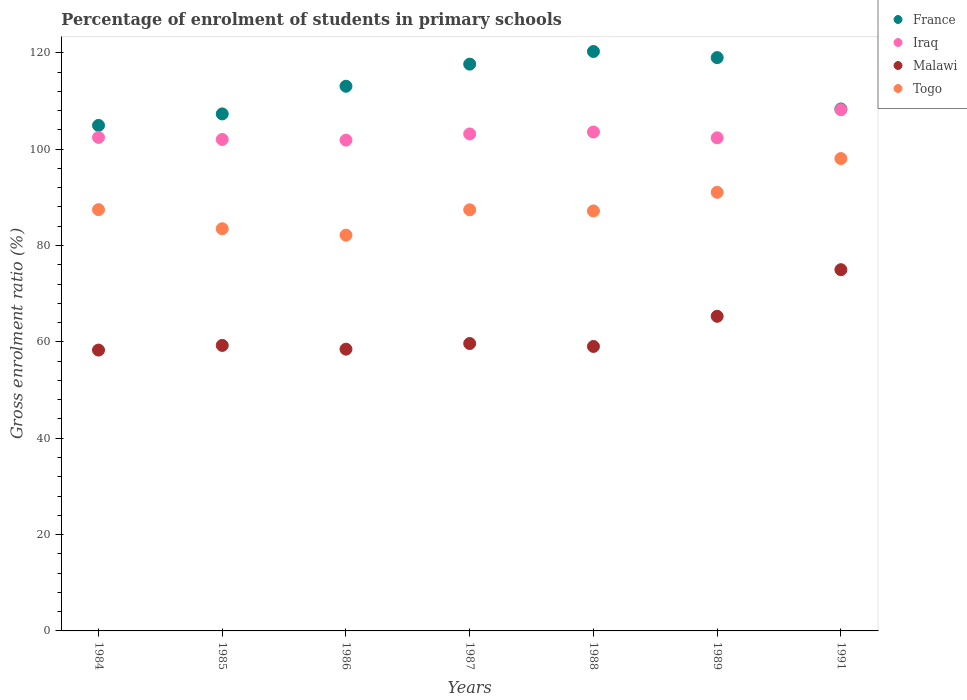How many different coloured dotlines are there?
Keep it short and to the point. 4. Is the number of dotlines equal to the number of legend labels?
Give a very brief answer. Yes. What is the percentage of students enrolled in primary schools in France in 1985?
Your answer should be very brief. 107.31. Across all years, what is the maximum percentage of students enrolled in primary schools in Malawi?
Make the answer very short. 74.98. Across all years, what is the minimum percentage of students enrolled in primary schools in France?
Provide a succinct answer. 104.93. What is the total percentage of students enrolled in primary schools in France in the graph?
Your answer should be very brief. 790.55. What is the difference between the percentage of students enrolled in primary schools in Malawi in 1985 and that in 1991?
Your response must be concise. -15.72. What is the difference between the percentage of students enrolled in primary schools in Iraq in 1985 and the percentage of students enrolled in primary schools in Malawi in 1989?
Your answer should be compact. 36.7. What is the average percentage of students enrolled in primary schools in Malawi per year?
Offer a very short reply. 62.15. In the year 1984, what is the difference between the percentage of students enrolled in primary schools in France and percentage of students enrolled in primary schools in Togo?
Your answer should be very brief. 17.49. What is the ratio of the percentage of students enrolled in primary schools in Iraq in 1984 to that in 1986?
Offer a terse response. 1.01. Is the difference between the percentage of students enrolled in primary schools in France in 1988 and 1989 greater than the difference between the percentage of students enrolled in primary schools in Togo in 1988 and 1989?
Ensure brevity in your answer.  Yes. What is the difference between the highest and the second highest percentage of students enrolled in primary schools in Malawi?
Ensure brevity in your answer.  9.67. What is the difference between the highest and the lowest percentage of students enrolled in primary schools in Togo?
Your answer should be very brief. 15.9. In how many years, is the percentage of students enrolled in primary schools in France greater than the average percentage of students enrolled in primary schools in France taken over all years?
Provide a short and direct response. 4. Is it the case that in every year, the sum of the percentage of students enrolled in primary schools in France and percentage of students enrolled in primary schools in Togo  is greater than the sum of percentage of students enrolled in primary schools in Malawi and percentage of students enrolled in primary schools in Iraq?
Provide a succinct answer. Yes. Does the percentage of students enrolled in primary schools in Togo monotonically increase over the years?
Offer a very short reply. No. Does the graph contain any zero values?
Your response must be concise. No. Does the graph contain grids?
Offer a very short reply. No. What is the title of the graph?
Offer a very short reply. Percentage of enrolment of students in primary schools. What is the label or title of the Y-axis?
Your answer should be compact. Gross enrolment ratio (%). What is the Gross enrolment ratio (%) in France in 1984?
Your response must be concise. 104.93. What is the Gross enrolment ratio (%) of Iraq in 1984?
Provide a succinct answer. 102.44. What is the Gross enrolment ratio (%) of Malawi in 1984?
Offer a very short reply. 58.29. What is the Gross enrolment ratio (%) of Togo in 1984?
Keep it short and to the point. 87.44. What is the Gross enrolment ratio (%) in France in 1985?
Keep it short and to the point. 107.31. What is the Gross enrolment ratio (%) of Iraq in 1985?
Your answer should be very brief. 102.01. What is the Gross enrolment ratio (%) in Malawi in 1985?
Your answer should be very brief. 59.26. What is the Gross enrolment ratio (%) of Togo in 1985?
Offer a very short reply. 83.48. What is the Gross enrolment ratio (%) in France in 1986?
Ensure brevity in your answer.  113.06. What is the Gross enrolment ratio (%) of Iraq in 1986?
Ensure brevity in your answer.  101.87. What is the Gross enrolment ratio (%) in Malawi in 1986?
Ensure brevity in your answer.  58.48. What is the Gross enrolment ratio (%) in Togo in 1986?
Give a very brief answer. 82.15. What is the Gross enrolment ratio (%) of France in 1987?
Provide a succinct answer. 117.64. What is the Gross enrolment ratio (%) of Iraq in 1987?
Ensure brevity in your answer.  103.16. What is the Gross enrolment ratio (%) of Malawi in 1987?
Your answer should be very brief. 59.66. What is the Gross enrolment ratio (%) of Togo in 1987?
Your answer should be compact. 87.41. What is the Gross enrolment ratio (%) of France in 1988?
Offer a very short reply. 120.27. What is the Gross enrolment ratio (%) in Iraq in 1988?
Provide a short and direct response. 103.56. What is the Gross enrolment ratio (%) of Malawi in 1988?
Your answer should be very brief. 59.04. What is the Gross enrolment ratio (%) in Togo in 1988?
Offer a terse response. 87.17. What is the Gross enrolment ratio (%) in France in 1989?
Ensure brevity in your answer.  119. What is the Gross enrolment ratio (%) in Iraq in 1989?
Your answer should be compact. 102.35. What is the Gross enrolment ratio (%) of Malawi in 1989?
Give a very brief answer. 65.31. What is the Gross enrolment ratio (%) in Togo in 1989?
Keep it short and to the point. 91.04. What is the Gross enrolment ratio (%) of France in 1991?
Your response must be concise. 108.34. What is the Gross enrolment ratio (%) of Iraq in 1991?
Offer a very short reply. 108.19. What is the Gross enrolment ratio (%) of Malawi in 1991?
Your response must be concise. 74.98. What is the Gross enrolment ratio (%) of Togo in 1991?
Your answer should be very brief. 98.04. Across all years, what is the maximum Gross enrolment ratio (%) in France?
Your answer should be very brief. 120.27. Across all years, what is the maximum Gross enrolment ratio (%) in Iraq?
Provide a short and direct response. 108.19. Across all years, what is the maximum Gross enrolment ratio (%) of Malawi?
Ensure brevity in your answer.  74.98. Across all years, what is the maximum Gross enrolment ratio (%) of Togo?
Your answer should be very brief. 98.04. Across all years, what is the minimum Gross enrolment ratio (%) of France?
Make the answer very short. 104.93. Across all years, what is the minimum Gross enrolment ratio (%) in Iraq?
Your response must be concise. 101.87. Across all years, what is the minimum Gross enrolment ratio (%) of Malawi?
Keep it short and to the point. 58.29. Across all years, what is the minimum Gross enrolment ratio (%) of Togo?
Give a very brief answer. 82.15. What is the total Gross enrolment ratio (%) in France in the graph?
Give a very brief answer. 790.55. What is the total Gross enrolment ratio (%) in Iraq in the graph?
Ensure brevity in your answer.  723.57. What is the total Gross enrolment ratio (%) of Malawi in the graph?
Your response must be concise. 435.02. What is the total Gross enrolment ratio (%) of Togo in the graph?
Provide a short and direct response. 616.73. What is the difference between the Gross enrolment ratio (%) of France in 1984 and that in 1985?
Make the answer very short. -2.38. What is the difference between the Gross enrolment ratio (%) in Iraq in 1984 and that in 1985?
Offer a very short reply. 0.43. What is the difference between the Gross enrolment ratio (%) in Malawi in 1984 and that in 1985?
Provide a short and direct response. -0.97. What is the difference between the Gross enrolment ratio (%) of Togo in 1984 and that in 1985?
Offer a terse response. 3.97. What is the difference between the Gross enrolment ratio (%) in France in 1984 and that in 1986?
Offer a very short reply. -8.12. What is the difference between the Gross enrolment ratio (%) of Iraq in 1984 and that in 1986?
Your response must be concise. 0.56. What is the difference between the Gross enrolment ratio (%) in Malawi in 1984 and that in 1986?
Your answer should be compact. -0.19. What is the difference between the Gross enrolment ratio (%) in Togo in 1984 and that in 1986?
Provide a short and direct response. 5.3. What is the difference between the Gross enrolment ratio (%) of France in 1984 and that in 1987?
Make the answer very short. -12.71. What is the difference between the Gross enrolment ratio (%) in Iraq in 1984 and that in 1987?
Offer a very short reply. -0.72. What is the difference between the Gross enrolment ratio (%) of Malawi in 1984 and that in 1987?
Offer a terse response. -1.36. What is the difference between the Gross enrolment ratio (%) in Togo in 1984 and that in 1987?
Make the answer very short. 0.04. What is the difference between the Gross enrolment ratio (%) of France in 1984 and that in 1988?
Provide a succinct answer. -15.33. What is the difference between the Gross enrolment ratio (%) in Iraq in 1984 and that in 1988?
Give a very brief answer. -1.12. What is the difference between the Gross enrolment ratio (%) in Malawi in 1984 and that in 1988?
Provide a succinct answer. -0.75. What is the difference between the Gross enrolment ratio (%) in Togo in 1984 and that in 1988?
Your answer should be compact. 0.27. What is the difference between the Gross enrolment ratio (%) in France in 1984 and that in 1989?
Ensure brevity in your answer.  -14.07. What is the difference between the Gross enrolment ratio (%) of Iraq in 1984 and that in 1989?
Provide a short and direct response. 0.09. What is the difference between the Gross enrolment ratio (%) in Malawi in 1984 and that in 1989?
Your response must be concise. -7.01. What is the difference between the Gross enrolment ratio (%) in Togo in 1984 and that in 1989?
Your answer should be compact. -3.59. What is the difference between the Gross enrolment ratio (%) in France in 1984 and that in 1991?
Make the answer very short. -3.4. What is the difference between the Gross enrolment ratio (%) in Iraq in 1984 and that in 1991?
Keep it short and to the point. -5.75. What is the difference between the Gross enrolment ratio (%) of Malawi in 1984 and that in 1991?
Offer a very short reply. -16.69. What is the difference between the Gross enrolment ratio (%) of Togo in 1984 and that in 1991?
Offer a terse response. -10.6. What is the difference between the Gross enrolment ratio (%) in France in 1985 and that in 1986?
Offer a very short reply. -5.74. What is the difference between the Gross enrolment ratio (%) in Iraq in 1985 and that in 1986?
Your answer should be compact. 0.14. What is the difference between the Gross enrolment ratio (%) of Malawi in 1985 and that in 1986?
Offer a terse response. 0.78. What is the difference between the Gross enrolment ratio (%) of Togo in 1985 and that in 1986?
Offer a very short reply. 1.33. What is the difference between the Gross enrolment ratio (%) of France in 1985 and that in 1987?
Make the answer very short. -10.33. What is the difference between the Gross enrolment ratio (%) in Iraq in 1985 and that in 1987?
Give a very brief answer. -1.15. What is the difference between the Gross enrolment ratio (%) in Malawi in 1985 and that in 1987?
Provide a succinct answer. -0.39. What is the difference between the Gross enrolment ratio (%) of Togo in 1985 and that in 1987?
Offer a terse response. -3.93. What is the difference between the Gross enrolment ratio (%) in France in 1985 and that in 1988?
Give a very brief answer. -12.95. What is the difference between the Gross enrolment ratio (%) of Iraq in 1985 and that in 1988?
Your answer should be compact. -1.55. What is the difference between the Gross enrolment ratio (%) of Malawi in 1985 and that in 1988?
Give a very brief answer. 0.22. What is the difference between the Gross enrolment ratio (%) of Togo in 1985 and that in 1988?
Make the answer very short. -3.7. What is the difference between the Gross enrolment ratio (%) of France in 1985 and that in 1989?
Provide a succinct answer. -11.69. What is the difference between the Gross enrolment ratio (%) of Iraq in 1985 and that in 1989?
Give a very brief answer. -0.34. What is the difference between the Gross enrolment ratio (%) of Malawi in 1985 and that in 1989?
Give a very brief answer. -6.04. What is the difference between the Gross enrolment ratio (%) in Togo in 1985 and that in 1989?
Your answer should be compact. -7.56. What is the difference between the Gross enrolment ratio (%) of France in 1985 and that in 1991?
Your answer should be very brief. -1.02. What is the difference between the Gross enrolment ratio (%) of Iraq in 1985 and that in 1991?
Ensure brevity in your answer.  -6.18. What is the difference between the Gross enrolment ratio (%) in Malawi in 1985 and that in 1991?
Offer a very short reply. -15.72. What is the difference between the Gross enrolment ratio (%) of Togo in 1985 and that in 1991?
Your answer should be very brief. -14.57. What is the difference between the Gross enrolment ratio (%) of France in 1986 and that in 1987?
Ensure brevity in your answer.  -4.59. What is the difference between the Gross enrolment ratio (%) of Iraq in 1986 and that in 1987?
Make the answer very short. -1.28. What is the difference between the Gross enrolment ratio (%) of Malawi in 1986 and that in 1987?
Offer a very short reply. -1.17. What is the difference between the Gross enrolment ratio (%) in Togo in 1986 and that in 1987?
Make the answer very short. -5.26. What is the difference between the Gross enrolment ratio (%) in France in 1986 and that in 1988?
Provide a short and direct response. -7.21. What is the difference between the Gross enrolment ratio (%) of Iraq in 1986 and that in 1988?
Keep it short and to the point. -1.68. What is the difference between the Gross enrolment ratio (%) in Malawi in 1986 and that in 1988?
Ensure brevity in your answer.  -0.56. What is the difference between the Gross enrolment ratio (%) in Togo in 1986 and that in 1988?
Provide a succinct answer. -5.03. What is the difference between the Gross enrolment ratio (%) of France in 1986 and that in 1989?
Your answer should be compact. -5.94. What is the difference between the Gross enrolment ratio (%) of Iraq in 1986 and that in 1989?
Offer a terse response. -0.48. What is the difference between the Gross enrolment ratio (%) in Malawi in 1986 and that in 1989?
Keep it short and to the point. -6.82. What is the difference between the Gross enrolment ratio (%) of Togo in 1986 and that in 1989?
Offer a very short reply. -8.89. What is the difference between the Gross enrolment ratio (%) in France in 1986 and that in 1991?
Offer a very short reply. 4.72. What is the difference between the Gross enrolment ratio (%) of Iraq in 1986 and that in 1991?
Provide a short and direct response. -6.31. What is the difference between the Gross enrolment ratio (%) of Malawi in 1986 and that in 1991?
Ensure brevity in your answer.  -16.5. What is the difference between the Gross enrolment ratio (%) of Togo in 1986 and that in 1991?
Provide a short and direct response. -15.9. What is the difference between the Gross enrolment ratio (%) of France in 1987 and that in 1988?
Offer a terse response. -2.62. What is the difference between the Gross enrolment ratio (%) in Iraq in 1987 and that in 1988?
Provide a short and direct response. -0.4. What is the difference between the Gross enrolment ratio (%) in Malawi in 1987 and that in 1988?
Offer a very short reply. 0.61. What is the difference between the Gross enrolment ratio (%) in Togo in 1987 and that in 1988?
Provide a succinct answer. 0.23. What is the difference between the Gross enrolment ratio (%) in France in 1987 and that in 1989?
Give a very brief answer. -1.36. What is the difference between the Gross enrolment ratio (%) of Iraq in 1987 and that in 1989?
Offer a terse response. 0.8. What is the difference between the Gross enrolment ratio (%) of Malawi in 1987 and that in 1989?
Make the answer very short. -5.65. What is the difference between the Gross enrolment ratio (%) in Togo in 1987 and that in 1989?
Your answer should be compact. -3.63. What is the difference between the Gross enrolment ratio (%) of France in 1987 and that in 1991?
Provide a succinct answer. 9.31. What is the difference between the Gross enrolment ratio (%) in Iraq in 1987 and that in 1991?
Ensure brevity in your answer.  -5.03. What is the difference between the Gross enrolment ratio (%) of Malawi in 1987 and that in 1991?
Your answer should be compact. -15.32. What is the difference between the Gross enrolment ratio (%) of Togo in 1987 and that in 1991?
Offer a terse response. -10.64. What is the difference between the Gross enrolment ratio (%) of France in 1988 and that in 1989?
Provide a succinct answer. 1.27. What is the difference between the Gross enrolment ratio (%) in Iraq in 1988 and that in 1989?
Provide a succinct answer. 1.2. What is the difference between the Gross enrolment ratio (%) of Malawi in 1988 and that in 1989?
Your answer should be compact. -6.26. What is the difference between the Gross enrolment ratio (%) of Togo in 1988 and that in 1989?
Give a very brief answer. -3.87. What is the difference between the Gross enrolment ratio (%) of France in 1988 and that in 1991?
Provide a succinct answer. 11.93. What is the difference between the Gross enrolment ratio (%) in Iraq in 1988 and that in 1991?
Offer a terse response. -4.63. What is the difference between the Gross enrolment ratio (%) in Malawi in 1988 and that in 1991?
Ensure brevity in your answer.  -15.94. What is the difference between the Gross enrolment ratio (%) of Togo in 1988 and that in 1991?
Give a very brief answer. -10.87. What is the difference between the Gross enrolment ratio (%) in France in 1989 and that in 1991?
Your answer should be compact. 10.66. What is the difference between the Gross enrolment ratio (%) in Iraq in 1989 and that in 1991?
Your answer should be very brief. -5.83. What is the difference between the Gross enrolment ratio (%) in Malawi in 1989 and that in 1991?
Provide a succinct answer. -9.67. What is the difference between the Gross enrolment ratio (%) of Togo in 1989 and that in 1991?
Your response must be concise. -7. What is the difference between the Gross enrolment ratio (%) of France in 1984 and the Gross enrolment ratio (%) of Iraq in 1985?
Your answer should be compact. 2.92. What is the difference between the Gross enrolment ratio (%) in France in 1984 and the Gross enrolment ratio (%) in Malawi in 1985?
Make the answer very short. 45.67. What is the difference between the Gross enrolment ratio (%) in France in 1984 and the Gross enrolment ratio (%) in Togo in 1985?
Your answer should be compact. 21.46. What is the difference between the Gross enrolment ratio (%) in Iraq in 1984 and the Gross enrolment ratio (%) in Malawi in 1985?
Ensure brevity in your answer.  43.18. What is the difference between the Gross enrolment ratio (%) in Iraq in 1984 and the Gross enrolment ratio (%) in Togo in 1985?
Your answer should be very brief. 18.96. What is the difference between the Gross enrolment ratio (%) in Malawi in 1984 and the Gross enrolment ratio (%) in Togo in 1985?
Provide a short and direct response. -25.18. What is the difference between the Gross enrolment ratio (%) of France in 1984 and the Gross enrolment ratio (%) of Iraq in 1986?
Your answer should be compact. 3.06. What is the difference between the Gross enrolment ratio (%) of France in 1984 and the Gross enrolment ratio (%) of Malawi in 1986?
Make the answer very short. 46.45. What is the difference between the Gross enrolment ratio (%) in France in 1984 and the Gross enrolment ratio (%) in Togo in 1986?
Give a very brief answer. 22.79. What is the difference between the Gross enrolment ratio (%) of Iraq in 1984 and the Gross enrolment ratio (%) of Malawi in 1986?
Provide a succinct answer. 43.96. What is the difference between the Gross enrolment ratio (%) of Iraq in 1984 and the Gross enrolment ratio (%) of Togo in 1986?
Offer a terse response. 20.29. What is the difference between the Gross enrolment ratio (%) in Malawi in 1984 and the Gross enrolment ratio (%) in Togo in 1986?
Your answer should be compact. -23.85. What is the difference between the Gross enrolment ratio (%) of France in 1984 and the Gross enrolment ratio (%) of Iraq in 1987?
Your answer should be compact. 1.78. What is the difference between the Gross enrolment ratio (%) in France in 1984 and the Gross enrolment ratio (%) in Malawi in 1987?
Make the answer very short. 45.28. What is the difference between the Gross enrolment ratio (%) of France in 1984 and the Gross enrolment ratio (%) of Togo in 1987?
Your response must be concise. 17.53. What is the difference between the Gross enrolment ratio (%) of Iraq in 1984 and the Gross enrolment ratio (%) of Malawi in 1987?
Provide a short and direct response. 42.78. What is the difference between the Gross enrolment ratio (%) of Iraq in 1984 and the Gross enrolment ratio (%) of Togo in 1987?
Make the answer very short. 15.03. What is the difference between the Gross enrolment ratio (%) in Malawi in 1984 and the Gross enrolment ratio (%) in Togo in 1987?
Ensure brevity in your answer.  -29.11. What is the difference between the Gross enrolment ratio (%) of France in 1984 and the Gross enrolment ratio (%) of Iraq in 1988?
Offer a very short reply. 1.38. What is the difference between the Gross enrolment ratio (%) of France in 1984 and the Gross enrolment ratio (%) of Malawi in 1988?
Provide a succinct answer. 45.89. What is the difference between the Gross enrolment ratio (%) in France in 1984 and the Gross enrolment ratio (%) in Togo in 1988?
Keep it short and to the point. 17.76. What is the difference between the Gross enrolment ratio (%) of Iraq in 1984 and the Gross enrolment ratio (%) of Malawi in 1988?
Give a very brief answer. 43.39. What is the difference between the Gross enrolment ratio (%) in Iraq in 1984 and the Gross enrolment ratio (%) in Togo in 1988?
Your answer should be very brief. 15.27. What is the difference between the Gross enrolment ratio (%) in Malawi in 1984 and the Gross enrolment ratio (%) in Togo in 1988?
Keep it short and to the point. -28.88. What is the difference between the Gross enrolment ratio (%) of France in 1984 and the Gross enrolment ratio (%) of Iraq in 1989?
Give a very brief answer. 2.58. What is the difference between the Gross enrolment ratio (%) in France in 1984 and the Gross enrolment ratio (%) in Malawi in 1989?
Your answer should be compact. 39.63. What is the difference between the Gross enrolment ratio (%) in France in 1984 and the Gross enrolment ratio (%) in Togo in 1989?
Provide a short and direct response. 13.89. What is the difference between the Gross enrolment ratio (%) in Iraq in 1984 and the Gross enrolment ratio (%) in Malawi in 1989?
Your response must be concise. 37.13. What is the difference between the Gross enrolment ratio (%) in Iraq in 1984 and the Gross enrolment ratio (%) in Togo in 1989?
Your answer should be very brief. 11.4. What is the difference between the Gross enrolment ratio (%) in Malawi in 1984 and the Gross enrolment ratio (%) in Togo in 1989?
Your answer should be very brief. -32.74. What is the difference between the Gross enrolment ratio (%) of France in 1984 and the Gross enrolment ratio (%) of Iraq in 1991?
Your answer should be compact. -3.25. What is the difference between the Gross enrolment ratio (%) in France in 1984 and the Gross enrolment ratio (%) in Malawi in 1991?
Give a very brief answer. 29.95. What is the difference between the Gross enrolment ratio (%) in France in 1984 and the Gross enrolment ratio (%) in Togo in 1991?
Provide a succinct answer. 6.89. What is the difference between the Gross enrolment ratio (%) of Iraq in 1984 and the Gross enrolment ratio (%) of Malawi in 1991?
Keep it short and to the point. 27.46. What is the difference between the Gross enrolment ratio (%) in Iraq in 1984 and the Gross enrolment ratio (%) in Togo in 1991?
Keep it short and to the point. 4.4. What is the difference between the Gross enrolment ratio (%) in Malawi in 1984 and the Gross enrolment ratio (%) in Togo in 1991?
Provide a short and direct response. -39.75. What is the difference between the Gross enrolment ratio (%) in France in 1985 and the Gross enrolment ratio (%) in Iraq in 1986?
Keep it short and to the point. 5.44. What is the difference between the Gross enrolment ratio (%) in France in 1985 and the Gross enrolment ratio (%) in Malawi in 1986?
Give a very brief answer. 48.83. What is the difference between the Gross enrolment ratio (%) of France in 1985 and the Gross enrolment ratio (%) of Togo in 1986?
Offer a terse response. 25.17. What is the difference between the Gross enrolment ratio (%) in Iraq in 1985 and the Gross enrolment ratio (%) in Malawi in 1986?
Offer a terse response. 43.53. What is the difference between the Gross enrolment ratio (%) in Iraq in 1985 and the Gross enrolment ratio (%) in Togo in 1986?
Provide a succinct answer. 19.86. What is the difference between the Gross enrolment ratio (%) in Malawi in 1985 and the Gross enrolment ratio (%) in Togo in 1986?
Ensure brevity in your answer.  -22.88. What is the difference between the Gross enrolment ratio (%) in France in 1985 and the Gross enrolment ratio (%) in Iraq in 1987?
Give a very brief answer. 4.16. What is the difference between the Gross enrolment ratio (%) in France in 1985 and the Gross enrolment ratio (%) in Malawi in 1987?
Give a very brief answer. 47.66. What is the difference between the Gross enrolment ratio (%) of France in 1985 and the Gross enrolment ratio (%) of Togo in 1987?
Keep it short and to the point. 19.91. What is the difference between the Gross enrolment ratio (%) in Iraq in 1985 and the Gross enrolment ratio (%) in Malawi in 1987?
Offer a very short reply. 42.35. What is the difference between the Gross enrolment ratio (%) of Iraq in 1985 and the Gross enrolment ratio (%) of Togo in 1987?
Provide a short and direct response. 14.6. What is the difference between the Gross enrolment ratio (%) of Malawi in 1985 and the Gross enrolment ratio (%) of Togo in 1987?
Make the answer very short. -28.14. What is the difference between the Gross enrolment ratio (%) in France in 1985 and the Gross enrolment ratio (%) in Iraq in 1988?
Give a very brief answer. 3.76. What is the difference between the Gross enrolment ratio (%) in France in 1985 and the Gross enrolment ratio (%) in Malawi in 1988?
Provide a short and direct response. 48.27. What is the difference between the Gross enrolment ratio (%) in France in 1985 and the Gross enrolment ratio (%) in Togo in 1988?
Your response must be concise. 20.14. What is the difference between the Gross enrolment ratio (%) of Iraq in 1985 and the Gross enrolment ratio (%) of Malawi in 1988?
Your response must be concise. 42.96. What is the difference between the Gross enrolment ratio (%) of Iraq in 1985 and the Gross enrolment ratio (%) of Togo in 1988?
Provide a succinct answer. 14.84. What is the difference between the Gross enrolment ratio (%) of Malawi in 1985 and the Gross enrolment ratio (%) of Togo in 1988?
Your response must be concise. -27.91. What is the difference between the Gross enrolment ratio (%) in France in 1985 and the Gross enrolment ratio (%) in Iraq in 1989?
Provide a short and direct response. 4.96. What is the difference between the Gross enrolment ratio (%) in France in 1985 and the Gross enrolment ratio (%) in Malawi in 1989?
Offer a very short reply. 42.01. What is the difference between the Gross enrolment ratio (%) of France in 1985 and the Gross enrolment ratio (%) of Togo in 1989?
Ensure brevity in your answer.  16.27. What is the difference between the Gross enrolment ratio (%) of Iraq in 1985 and the Gross enrolment ratio (%) of Malawi in 1989?
Keep it short and to the point. 36.7. What is the difference between the Gross enrolment ratio (%) of Iraq in 1985 and the Gross enrolment ratio (%) of Togo in 1989?
Offer a very short reply. 10.97. What is the difference between the Gross enrolment ratio (%) in Malawi in 1985 and the Gross enrolment ratio (%) in Togo in 1989?
Give a very brief answer. -31.78. What is the difference between the Gross enrolment ratio (%) in France in 1985 and the Gross enrolment ratio (%) in Iraq in 1991?
Your answer should be compact. -0.87. What is the difference between the Gross enrolment ratio (%) of France in 1985 and the Gross enrolment ratio (%) of Malawi in 1991?
Keep it short and to the point. 32.33. What is the difference between the Gross enrolment ratio (%) of France in 1985 and the Gross enrolment ratio (%) of Togo in 1991?
Your response must be concise. 9.27. What is the difference between the Gross enrolment ratio (%) in Iraq in 1985 and the Gross enrolment ratio (%) in Malawi in 1991?
Your response must be concise. 27.03. What is the difference between the Gross enrolment ratio (%) of Iraq in 1985 and the Gross enrolment ratio (%) of Togo in 1991?
Ensure brevity in your answer.  3.97. What is the difference between the Gross enrolment ratio (%) of Malawi in 1985 and the Gross enrolment ratio (%) of Togo in 1991?
Ensure brevity in your answer.  -38.78. What is the difference between the Gross enrolment ratio (%) of France in 1986 and the Gross enrolment ratio (%) of Iraq in 1987?
Offer a terse response. 9.9. What is the difference between the Gross enrolment ratio (%) of France in 1986 and the Gross enrolment ratio (%) of Malawi in 1987?
Make the answer very short. 53.4. What is the difference between the Gross enrolment ratio (%) of France in 1986 and the Gross enrolment ratio (%) of Togo in 1987?
Offer a terse response. 25.65. What is the difference between the Gross enrolment ratio (%) in Iraq in 1986 and the Gross enrolment ratio (%) in Malawi in 1987?
Ensure brevity in your answer.  42.22. What is the difference between the Gross enrolment ratio (%) of Iraq in 1986 and the Gross enrolment ratio (%) of Togo in 1987?
Offer a very short reply. 14.47. What is the difference between the Gross enrolment ratio (%) in Malawi in 1986 and the Gross enrolment ratio (%) in Togo in 1987?
Keep it short and to the point. -28.92. What is the difference between the Gross enrolment ratio (%) of France in 1986 and the Gross enrolment ratio (%) of Iraq in 1988?
Give a very brief answer. 9.5. What is the difference between the Gross enrolment ratio (%) of France in 1986 and the Gross enrolment ratio (%) of Malawi in 1988?
Your response must be concise. 54.01. What is the difference between the Gross enrolment ratio (%) in France in 1986 and the Gross enrolment ratio (%) in Togo in 1988?
Your response must be concise. 25.88. What is the difference between the Gross enrolment ratio (%) in Iraq in 1986 and the Gross enrolment ratio (%) in Malawi in 1988?
Your answer should be compact. 42.83. What is the difference between the Gross enrolment ratio (%) of Iraq in 1986 and the Gross enrolment ratio (%) of Togo in 1988?
Your response must be concise. 14.7. What is the difference between the Gross enrolment ratio (%) of Malawi in 1986 and the Gross enrolment ratio (%) of Togo in 1988?
Provide a succinct answer. -28.69. What is the difference between the Gross enrolment ratio (%) in France in 1986 and the Gross enrolment ratio (%) in Iraq in 1989?
Make the answer very short. 10.7. What is the difference between the Gross enrolment ratio (%) in France in 1986 and the Gross enrolment ratio (%) in Malawi in 1989?
Provide a succinct answer. 47.75. What is the difference between the Gross enrolment ratio (%) of France in 1986 and the Gross enrolment ratio (%) of Togo in 1989?
Offer a very short reply. 22.02. What is the difference between the Gross enrolment ratio (%) of Iraq in 1986 and the Gross enrolment ratio (%) of Malawi in 1989?
Offer a terse response. 36.57. What is the difference between the Gross enrolment ratio (%) in Iraq in 1986 and the Gross enrolment ratio (%) in Togo in 1989?
Your answer should be compact. 10.84. What is the difference between the Gross enrolment ratio (%) in Malawi in 1986 and the Gross enrolment ratio (%) in Togo in 1989?
Provide a succinct answer. -32.56. What is the difference between the Gross enrolment ratio (%) in France in 1986 and the Gross enrolment ratio (%) in Iraq in 1991?
Provide a succinct answer. 4.87. What is the difference between the Gross enrolment ratio (%) in France in 1986 and the Gross enrolment ratio (%) in Malawi in 1991?
Ensure brevity in your answer.  38.08. What is the difference between the Gross enrolment ratio (%) of France in 1986 and the Gross enrolment ratio (%) of Togo in 1991?
Give a very brief answer. 15.01. What is the difference between the Gross enrolment ratio (%) in Iraq in 1986 and the Gross enrolment ratio (%) in Malawi in 1991?
Your response must be concise. 26.89. What is the difference between the Gross enrolment ratio (%) in Iraq in 1986 and the Gross enrolment ratio (%) in Togo in 1991?
Your answer should be very brief. 3.83. What is the difference between the Gross enrolment ratio (%) of Malawi in 1986 and the Gross enrolment ratio (%) of Togo in 1991?
Offer a terse response. -39.56. What is the difference between the Gross enrolment ratio (%) of France in 1987 and the Gross enrolment ratio (%) of Iraq in 1988?
Keep it short and to the point. 14.09. What is the difference between the Gross enrolment ratio (%) of France in 1987 and the Gross enrolment ratio (%) of Malawi in 1988?
Your answer should be very brief. 58.6. What is the difference between the Gross enrolment ratio (%) of France in 1987 and the Gross enrolment ratio (%) of Togo in 1988?
Your answer should be very brief. 30.47. What is the difference between the Gross enrolment ratio (%) of Iraq in 1987 and the Gross enrolment ratio (%) of Malawi in 1988?
Offer a very short reply. 44.11. What is the difference between the Gross enrolment ratio (%) in Iraq in 1987 and the Gross enrolment ratio (%) in Togo in 1988?
Provide a succinct answer. 15.98. What is the difference between the Gross enrolment ratio (%) of Malawi in 1987 and the Gross enrolment ratio (%) of Togo in 1988?
Give a very brief answer. -27.52. What is the difference between the Gross enrolment ratio (%) of France in 1987 and the Gross enrolment ratio (%) of Iraq in 1989?
Provide a succinct answer. 15.29. What is the difference between the Gross enrolment ratio (%) in France in 1987 and the Gross enrolment ratio (%) in Malawi in 1989?
Provide a short and direct response. 52.34. What is the difference between the Gross enrolment ratio (%) of France in 1987 and the Gross enrolment ratio (%) of Togo in 1989?
Your answer should be compact. 26.6. What is the difference between the Gross enrolment ratio (%) in Iraq in 1987 and the Gross enrolment ratio (%) in Malawi in 1989?
Keep it short and to the point. 37.85. What is the difference between the Gross enrolment ratio (%) of Iraq in 1987 and the Gross enrolment ratio (%) of Togo in 1989?
Your answer should be very brief. 12.12. What is the difference between the Gross enrolment ratio (%) of Malawi in 1987 and the Gross enrolment ratio (%) of Togo in 1989?
Your response must be concise. -31.38. What is the difference between the Gross enrolment ratio (%) of France in 1987 and the Gross enrolment ratio (%) of Iraq in 1991?
Ensure brevity in your answer.  9.46. What is the difference between the Gross enrolment ratio (%) of France in 1987 and the Gross enrolment ratio (%) of Malawi in 1991?
Ensure brevity in your answer.  42.66. What is the difference between the Gross enrolment ratio (%) of France in 1987 and the Gross enrolment ratio (%) of Togo in 1991?
Keep it short and to the point. 19.6. What is the difference between the Gross enrolment ratio (%) in Iraq in 1987 and the Gross enrolment ratio (%) in Malawi in 1991?
Make the answer very short. 28.18. What is the difference between the Gross enrolment ratio (%) of Iraq in 1987 and the Gross enrolment ratio (%) of Togo in 1991?
Keep it short and to the point. 5.11. What is the difference between the Gross enrolment ratio (%) in Malawi in 1987 and the Gross enrolment ratio (%) in Togo in 1991?
Ensure brevity in your answer.  -38.39. What is the difference between the Gross enrolment ratio (%) of France in 1988 and the Gross enrolment ratio (%) of Iraq in 1989?
Provide a short and direct response. 17.91. What is the difference between the Gross enrolment ratio (%) of France in 1988 and the Gross enrolment ratio (%) of Malawi in 1989?
Ensure brevity in your answer.  54.96. What is the difference between the Gross enrolment ratio (%) in France in 1988 and the Gross enrolment ratio (%) in Togo in 1989?
Your answer should be compact. 29.23. What is the difference between the Gross enrolment ratio (%) of Iraq in 1988 and the Gross enrolment ratio (%) of Malawi in 1989?
Your answer should be very brief. 38.25. What is the difference between the Gross enrolment ratio (%) in Iraq in 1988 and the Gross enrolment ratio (%) in Togo in 1989?
Your answer should be compact. 12.52. What is the difference between the Gross enrolment ratio (%) in Malawi in 1988 and the Gross enrolment ratio (%) in Togo in 1989?
Keep it short and to the point. -31.99. What is the difference between the Gross enrolment ratio (%) of France in 1988 and the Gross enrolment ratio (%) of Iraq in 1991?
Offer a terse response. 12.08. What is the difference between the Gross enrolment ratio (%) in France in 1988 and the Gross enrolment ratio (%) in Malawi in 1991?
Your answer should be compact. 45.29. What is the difference between the Gross enrolment ratio (%) of France in 1988 and the Gross enrolment ratio (%) of Togo in 1991?
Keep it short and to the point. 22.22. What is the difference between the Gross enrolment ratio (%) in Iraq in 1988 and the Gross enrolment ratio (%) in Malawi in 1991?
Make the answer very short. 28.58. What is the difference between the Gross enrolment ratio (%) in Iraq in 1988 and the Gross enrolment ratio (%) in Togo in 1991?
Offer a very short reply. 5.51. What is the difference between the Gross enrolment ratio (%) in Malawi in 1988 and the Gross enrolment ratio (%) in Togo in 1991?
Offer a terse response. -39. What is the difference between the Gross enrolment ratio (%) of France in 1989 and the Gross enrolment ratio (%) of Iraq in 1991?
Provide a succinct answer. 10.81. What is the difference between the Gross enrolment ratio (%) of France in 1989 and the Gross enrolment ratio (%) of Malawi in 1991?
Keep it short and to the point. 44.02. What is the difference between the Gross enrolment ratio (%) in France in 1989 and the Gross enrolment ratio (%) in Togo in 1991?
Provide a short and direct response. 20.96. What is the difference between the Gross enrolment ratio (%) of Iraq in 1989 and the Gross enrolment ratio (%) of Malawi in 1991?
Offer a terse response. 27.37. What is the difference between the Gross enrolment ratio (%) of Iraq in 1989 and the Gross enrolment ratio (%) of Togo in 1991?
Keep it short and to the point. 4.31. What is the difference between the Gross enrolment ratio (%) in Malawi in 1989 and the Gross enrolment ratio (%) in Togo in 1991?
Your answer should be very brief. -32.74. What is the average Gross enrolment ratio (%) in France per year?
Offer a very short reply. 112.94. What is the average Gross enrolment ratio (%) of Iraq per year?
Provide a succinct answer. 103.37. What is the average Gross enrolment ratio (%) of Malawi per year?
Your answer should be very brief. 62.15. What is the average Gross enrolment ratio (%) of Togo per year?
Keep it short and to the point. 88.1. In the year 1984, what is the difference between the Gross enrolment ratio (%) in France and Gross enrolment ratio (%) in Iraq?
Ensure brevity in your answer.  2.49. In the year 1984, what is the difference between the Gross enrolment ratio (%) in France and Gross enrolment ratio (%) in Malawi?
Provide a succinct answer. 46.64. In the year 1984, what is the difference between the Gross enrolment ratio (%) of France and Gross enrolment ratio (%) of Togo?
Give a very brief answer. 17.49. In the year 1984, what is the difference between the Gross enrolment ratio (%) of Iraq and Gross enrolment ratio (%) of Malawi?
Ensure brevity in your answer.  44.14. In the year 1984, what is the difference between the Gross enrolment ratio (%) of Iraq and Gross enrolment ratio (%) of Togo?
Offer a very short reply. 14.99. In the year 1984, what is the difference between the Gross enrolment ratio (%) of Malawi and Gross enrolment ratio (%) of Togo?
Provide a short and direct response. -29.15. In the year 1985, what is the difference between the Gross enrolment ratio (%) in France and Gross enrolment ratio (%) in Iraq?
Offer a terse response. 5.3. In the year 1985, what is the difference between the Gross enrolment ratio (%) of France and Gross enrolment ratio (%) of Malawi?
Make the answer very short. 48.05. In the year 1985, what is the difference between the Gross enrolment ratio (%) in France and Gross enrolment ratio (%) in Togo?
Your answer should be very brief. 23.84. In the year 1985, what is the difference between the Gross enrolment ratio (%) of Iraq and Gross enrolment ratio (%) of Malawi?
Your response must be concise. 42.75. In the year 1985, what is the difference between the Gross enrolment ratio (%) in Iraq and Gross enrolment ratio (%) in Togo?
Make the answer very short. 18.53. In the year 1985, what is the difference between the Gross enrolment ratio (%) of Malawi and Gross enrolment ratio (%) of Togo?
Keep it short and to the point. -24.22. In the year 1986, what is the difference between the Gross enrolment ratio (%) of France and Gross enrolment ratio (%) of Iraq?
Ensure brevity in your answer.  11.18. In the year 1986, what is the difference between the Gross enrolment ratio (%) in France and Gross enrolment ratio (%) in Malawi?
Make the answer very short. 54.57. In the year 1986, what is the difference between the Gross enrolment ratio (%) of France and Gross enrolment ratio (%) of Togo?
Your answer should be very brief. 30.91. In the year 1986, what is the difference between the Gross enrolment ratio (%) in Iraq and Gross enrolment ratio (%) in Malawi?
Provide a succinct answer. 43.39. In the year 1986, what is the difference between the Gross enrolment ratio (%) in Iraq and Gross enrolment ratio (%) in Togo?
Offer a very short reply. 19.73. In the year 1986, what is the difference between the Gross enrolment ratio (%) of Malawi and Gross enrolment ratio (%) of Togo?
Offer a very short reply. -23.66. In the year 1987, what is the difference between the Gross enrolment ratio (%) of France and Gross enrolment ratio (%) of Iraq?
Offer a terse response. 14.49. In the year 1987, what is the difference between the Gross enrolment ratio (%) in France and Gross enrolment ratio (%) in Malawi?
Your answer should be compact. 57.99. In the year 1987, what is the difference between the Gross enrolment ratio (%) in France and Gross enrolment ratio (%) in Togo?
Provide a succinct answer. 30.24. In the year 1987, what is the difference between the Gross enrolment ratio (%) of Iraq and Gross enrolment ratio (%) of Malawi?
Give a very brief answer. 43.5. In the year 1987, what is the difference between the Gross enrolment ratio (%) of Iraq and Gross enrolment ratio (%) of Togo?
Make the answer very short. 15.75. In the year 1987, what is the difference between the Gross enrolment ratio (%) in Malawi and Gross enrolment ratio (%) in Togo?
Offer a terse response. -27.75. In the year 1988, what is the difference between the Gross enrolment ratio (%) of France and Gross enrolment ratio (%) of Iraq?
Make the answer very short. 16.71. In the year 1988, what is the difference between the Gross enrolment ratio (%) in France and Gross enrolment ratio (%) in Malawi?
Provide a succinct answer. 61.22. In the year 1988, what is the difference between the Gross enrolment ratio (%) of France and Gross enrolment ratio (%) of Togo?
Ensure brevity in your answer.  33.09. In the year 1988, what is the difference between the Gross enrolment ratio (%) in Iraq and Gross enrolment ratio (%) in Malawi?
Provide a succinct answer. 44.51. In the year 1988, what is the difference between the Gross enrolment ratio (%) of Iraq and Gross enrolment ratio (%) of Togo?
Your answer should be very brief. 16.38. In the year 1988, what is the difference between the Gross enrolment ratio (%) of Malawi and Gross enrolment ratio (%) of Togo?
Give a very brief answer. -28.13. In the year 1989, what is the difference between the Gross enrolment ratio (%) of France and Gross enrolment ratio (%) of Iraq?
Provide a succinct answer. 16.65. In the year 1989, what is the difference between the Gross enrolment ratio (%) in France and Gross enrolment ratio (%) in Malawi?
Your response must be concise. 53.69. In the year 1989, what is the difference between the Gross enrolment ratio (%) of France and Gross enrolment ratio (%) of Togo?
Offer a very short reply. 27.96. In the year 1989, what is the difference between the Gross enrolment ratio (%) in Iraq and Gross enrolment ratio (%) in Malawi?
Ensure brevity in your answer.  37.05. In the year 1989, what is the difference between the Gross enrolment ratio (%) in Iraq and Gross enrolment ratio (%) in Togo?
Keep it short and to the point. 11.31. In the year 1989, what is the difference between the Gross enrolment ratio (%) of Malawi and Gross enrolment ratio (%) of Togo?
Make the answer very short. -25.73. In the year 1991, what is the difference between the Gross enrolment ratio (%) of France and Gross enrolment ratio (%) of Iraq?
Provide a succinct answer. 0.15. In the year 1991, what is the difference between the Gross enrolment ratio (%) in France and Gross enrolment ratio (%) in Malawi?
Offer a very short reply. 33.36. In the year 1991, what is the difference between the Gross enrolment ratio (%) in France and Gross enrolment ratio (%) in Togo?
Make the answer very short. 10.29. In the year 1991, what is the difference between the Gross enrolment ratio (%) of Iraq and Gross enrolment ratio (%) of Malawi?
Ensure brevity in your answer.  33.21. In the year 1991, what is the difference between the Gross enrolment ratio (%) in Iraq and Gross enrolment ratio (%) in Togo?
Offer a terse response. 10.14. In the year 1991, what is the difference between the Gross enrolment ratio (%) in Malawi and Gross enrolment ratio (%) in Togo?
Make the answer very short. -23.06. What is the ratio of the Gross enrolment ratio (%) in France in 1984 to that in 1985?
Make the answer very short. 0.98. What is the ratio of the Gross enrolment ratio (%) of Malawi in 1984 to that in 1985?
Ensure brevity in your answer.  0.98. What is the ratio of the Gross enrolment ratio (%) in Togo in 1984 to that in 1985?
Offer a terse response. 1.05. What is the ratio of the Gross enrolment ratio (%) of France in 1984 to that in 1986?
Give a very brief answer. 0.93. What is the ratio of the Gross enrolment ratio (%) of Malawi in 1984 to that in 1986?
Make the answer very short. 1. What is the ratio of the Gross enrolment ratio (%) in Togo in 1984 to that in 1986?
Your response must be concise. 1.06. What is the ratio of the Gross enrolment ratio (%) in France in 1984 to that in 1987?
Ensure brevity in your answer.  0.89. What is the ratio of the Gross enrolment ratio (%) of Malawi in 1984 to that in 1987?
Make the answer very short. 0.98. What is the ratio of the Gross enrolment ratio (%) of France in 1984 to that in 1988?
Your answer should be compact. 0.87. What is the ratio of the Gross enrolment ratio (%) in Malawi in 1984 to that in 1988?
Your response must be concise. 0.99. What is the ratio of the Gross enrolment ratio (%) in France in 1984 to that in 1989?
Provide a succinct answer. 0.88. What is the ratio of the Gross enrolment ratio (%) in Iraq in 1984 to that in 1989?
Keep it short and to the point. 1. What is the ratio of the Gross enrolment ratio (%) in Malawi in 1984 to that in 1989?
Make the answer very short. 0.89. What is the ratio of the Gross enrolment ratio (%) in Togo in 1984 to that in 1989?
Your answer should be very brief. 0.96. What is the ratio of the Gross enrolment ratio (%) of France in 1984 to that in 1991?
Make the answer very short. 0.97. What is the ratio of the Gross enrolment ratio (%) in Iraq in 1984 to that in 1991?
Offer a terse response. 0.95. What is the ratio of the Gross enrolment ratio (%) of Malawi in 1984 to that in 1991?
Ensure brevity in your answer.  0.78. What is the ratio of the Gross enrolment ratio (%) in Togo in 1984 to that in 1991?
Offer a terse response. 0.89. What is the ratio of the Gross enrolment ratio (%) in France in 1985 to that in 1986?
Offer a terse response. 0.95. What is the ratio of the Gross enrolment ratio (%) in Malawi in 1985 to that in 1986?
Ensure brevity in your answer.  1.01. What is the ratio of the Gross enrolment ratio (%) in Togo in 1985 to that in 1986?
Ensure brevity in your answer.  1.02. What is the ratio of the Gross enrolment ratio (%) of France in 1985 to that in 1987?
Provide a short and direct response. 0.91. What is the ratio of the Gross enrolment ratio (%) in Iraq in 1985 to that in 1987?
Your response must be concise. 0.99. What is the ratio of the Gross enrolment ratio (%) of Malawi in 1985 to that in 1987?
Provide a short and direct response. 0.99. What is the ratio of the Gross enrolment ratio (%) of Togo in 1985 to that in 1987?
Provide a short and direct response. 0.96. What is the ratio of the Gross enrolment ratio (%) in France in 1985 to that in 1988?
Provide a short and direct response. 0.89. What is the ratio of the Gross enrolment ratio (%) of Iraq in 1985 to that in 1988?
Make the answer very short. 0.99. What is the ratio of the Gross enrolment ratio (%) in Malawi in 1985 to that in 1988?
Provide a short and direct response. 1. What is the ratio of the Gross enrolment ratio (%) in Togo in 1985 to that in 1988?
Keep it short and to the point. 0.96. What is the ratio of the Gross enrolment ratio (%) of France in 1985 to that in 1989?
Your answer should be very brief. 0.9. What is the ratio of the Gross enrolment ratio (%) in Malawi in 1985 to that in 1989?
Ensure brevity in your answer.  0.91. What is the ratio of the Gross enrolment ratio (%) of Togo in 1985 to that in 1989?
Your response must be concise. 0.92. What is the ratio of the Gross enrolment ratio (%) in France in 1985 to that in 1991?
Your response must be concise. 0.99. What is the ratio of the Gross enrolment ratio (%) of Iraq in 1985 to that in 1991?
Provide a succinct answer. 0.94. What is the ratio of the Gross enrolment ratio (%) in Malawi in 1985 to that in 1991?
Ensure brevity in your answer.  0.79. What is the ratio of the Gross enrolment ratio (%) of Togo in 1985 to that in 1991?
Ensure brevity in your answer.  0.85. What is the ratio of the Gross enrolment ratio (%) in France in 1986 to that in 1987?
Your answer should be compact. 0.96. What is the ratio of the Gross enrolment ratio (%) in Iraq in 1986 to that in 1987?
Your response must be concise. 0.99. What is the ratio of the Gross enrolment ratio (%) in Malawi in 1986 to that in 1987?
Offer a terse response. 0.98. What is the ratio of the Gross enrolment ratio (%) of Togo in 1986 to that in 1987?
Your answer should be compact. 0.94. What is the ratio of the Gross enrolment ratio (%) in France in 1986 to that in 1988?
Give a very brief answer. 0.94. What is the ratio of the Gross enrolment ratio (%) in Iraq in 1986 to that in 1988?
Make the answer very short. 0.98. What is the ratio of the Gross enrolment ratio (%) of Malawi in 1986 to that in 1988?
Ensure brevity in your answer.  0.99. What is the ratio of the Gross enrolment ratio (%) in Togo in 1986 to that in 1988?
Provide a succinct answer. 0.94. What is the ratio of the Gross enrolment ratio (%) of France in 1986 to that in 1989?
Make the answer very short. 0.95. What is the ratio of the Gross enrolment ratio (%) in Malawi in 1986 to that in 1989?
Give a very brief answer. 0.9. What is the ratio of the Gross enrolment ratio (%) in Togo in 1986 to that in 1989?
Offer a very short reply. 0.9. What is the ratio of the Gross enrolment ratio (%) of France in 1986 to that in 1991?
Give a very brief answer. 1.04. What is the ratio of the Gross enrolment ratio (%) in Iraq in 1986 to that in 1991?
Ensure brevity in your answer.  0.94. What is the ratio of the Gross enrolment ratio (%) of Malawi in 1986 to that in 1991?
Your answer should be very brief. 0.78. What is the ratio of the Gross enrolment ratio (%) of Togo in 1986 to that in 1991?
Provide a short and direct response. 0.84. What is the ratio of the Gross enrolment ratio (%) of France in 1987 to that in 1988?
Your answer should be very brief. 0.98. What is the ratio of the Gross enrolment ratio (%) of Iraq in 1987 to that in 1988?
Offer a terse response. 1. What is the ratio of the Gross enrolment ratio (%) of Malawi in 1987 to that in 1988?
Provide a succinct answer. 1.01. What is the ratio of the Gross enrolment ratio (%) of France in 1987 to that in 1989?
Keep it short and to the point. 0.99. What is the ratio of the Gross enrolment ratio (%) in Malawi in 1987 to that in 1989?
Provide a succinct answer. 0.91. What is the ratio of the Gross enrolment ratio (%) of Togo in 1987 to that in 1989?
Provide a short and direct response. 0.96. What is the ratio of the Gross enrolment ratio (%) of France in 1987 to that in 1991?
Your response must be concise. 1.09. What is the ratio of the Gross enrolment ratio (%) of Iraq in 1987 to that in 1991?
Your answer should be compact. 0.95. What is the ratio of the Gross enrolment ratio (%) in Malawi in 1987 to that in 1991?
Provide a short and direct response. 0.8. What is the ratio of the Gross enrolment ratio (%) of Togo in 1987 to that in 1991?
Give a very brief answer. 0.89. What is the ratio of the Gross enrolment ratio (%) in France in 1988 to that in 1989?
Make the answer very short. 1.01. What is the ratio of the Gross enrolment ratio (%) in Iraq in 1988 to that in 1989?
Provide a succinct answer. 1.01. What is the ratio of the Gross enrolment ratio (%) of Malawi in 1988 to that in 1989?
Keep it short and to the point. 0.9. What is the ratio of the Gross enrolment ratio (%) of Togo in 1988 to that in 1989?
Give a very brief answer. 0.96. What is the ratio of the Gross enrolment ratio (%) in France in 1988 to that in 1991?
Make the answer very short. 1.11. What is the ratio of the Gross enrolment ratio (%) of Iraq in 1988 to that in 1991?
Ensure brevity in your answer.  0.96. What is the ratio of the Gross enrolment ratio (%) in Malawi in 1988 to that in 1991?
Your answer should be compact. 0.79. What is the ratio of the Gross enrolment ratio (%) in Togo in 1988 to that in 1991?
Offer a terse response. 0.89. What is the ratio of the Gross enrolment ratio (%) in France in 1989 to that in 1991?
Offer a very short reply. 1.1. What is the ratio of the Gross enrolment ratio (%) of Iraq in 1989 to that in 1991?
Your answer should be very brief. 0.95. What is the ratio of the Gross enrolment ratio (%) of Malawi in 1989 to that in 1991?
Provide a succinct answer. 0.87. What is the ratio of the Gross enrolment ratio (%) of Togo in 1989 to that in 1991?
Your answer should be compact. 0.93. What is the difference between the highest and the second highest Gross enrolment ratio (%) in France?
Keep it short and to the point. 1.27. What is the difference between the highest and the second highest Gross enrolment ratio (%) of Iraq?
Provide a short and direct response. 4.63. What is the difference between the highest and the second highest Gross enrolment ratio (%) in Malawi?
Provide a succinct answer. 9.67. What is the difference between the highest and the second highest Gross enrolment ratio (%) of Togo?
Your response must be concise. 7. What is the difference between the highest and the lowest Gross enrolment ratio (%) in France?
Your answer should be very brief. 15.33. What is the difference between the highest and the lowest Gross enrolment ratio (%) of Iraq?
Offer a very short reply. 6.31. What is the difference between the highest and the lowest Gross enrolment ratio (%) in Malawi?
Ensure brevity in your answer.  16.69. What is the difference between the highest and the lowest Gross enrolment ratio (%) of Togo?
Your answer should be very brief. 15.9. 